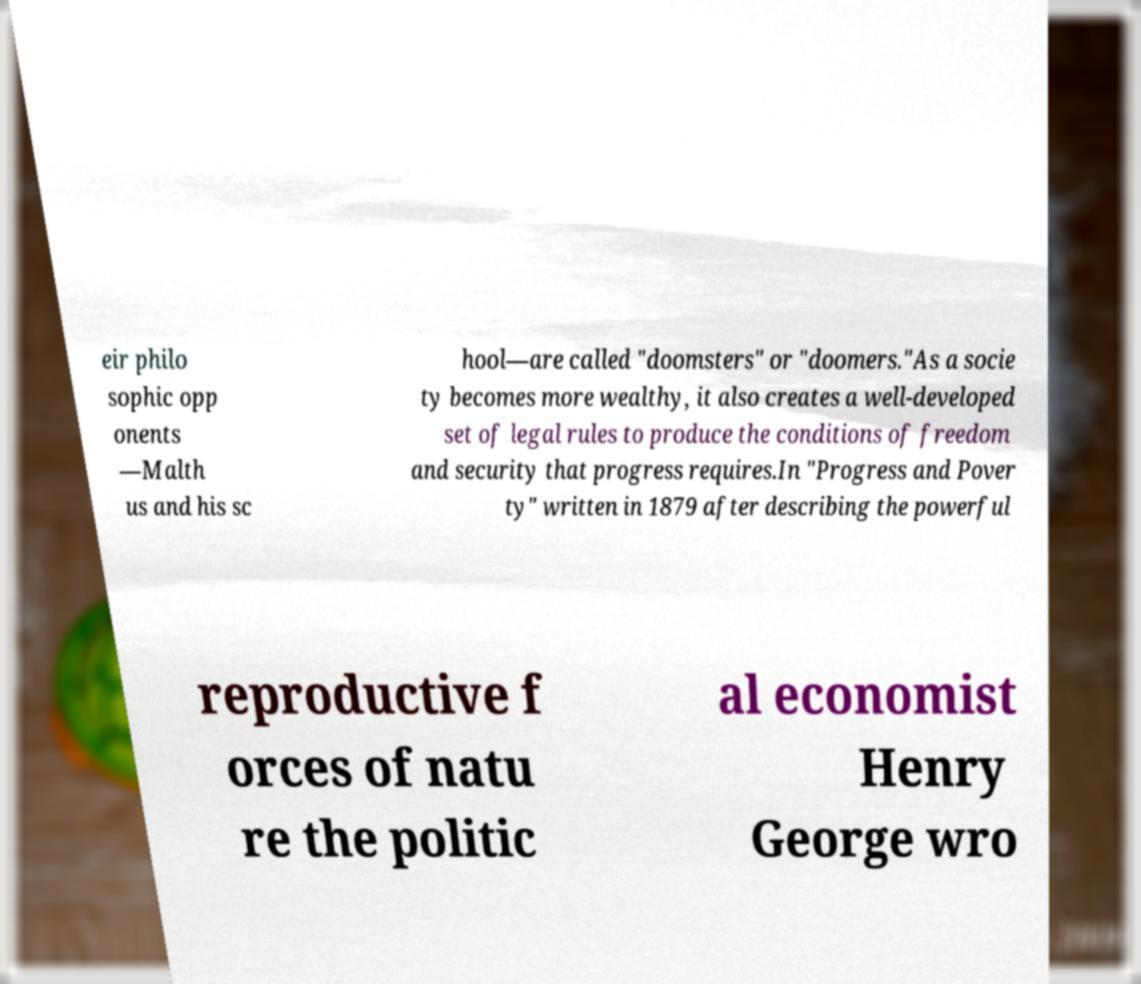Can you read and provide the text displayed in the image?This photo seems to have some interesting text. Can you extract and type it out for me? eir philo sophic opp onents —Malth us and his sc hool—are called "doomsters" or "doomers."As a socie ty becomes more wealthy, it also creates a well-developed set of legal rules to produce the conditions of freedom and security that progress requires.In "Progress and Pover ty" written in 1879 after describing the powerful reproductive f orces of natu re the politic al economist Henry George wro 